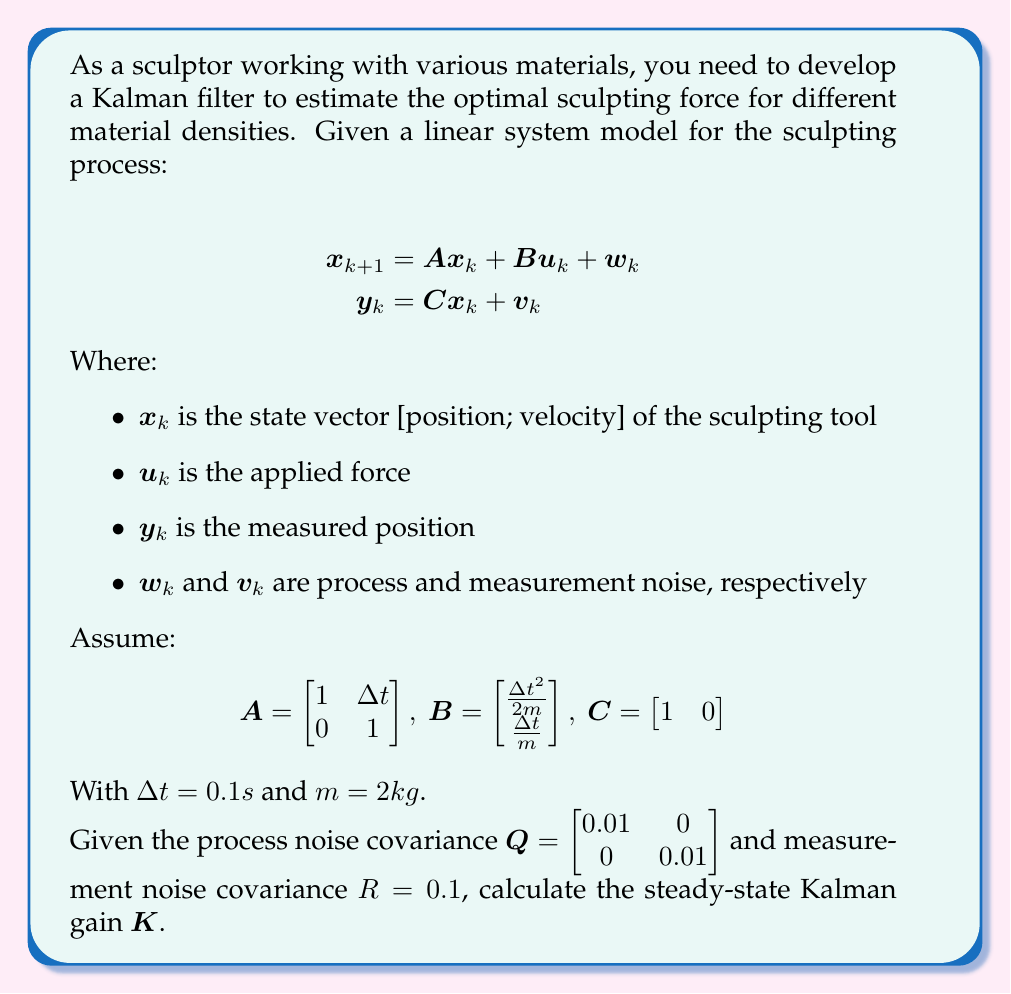Solve this math problem. To calculate the steady-state Kalman gain, we need to solve the discrete-time algebraic Riccati equation (DARE) and then use the resulting steady-state error covariance matrix to compute the gain. Let's follow these steps:

1. First, let's calculate the matrices A and B:

$$A = \begin{bmatrix} 1 & 0.1 \\ 0 & 1 \end{bmatrix}$$

$$B = \begin{bmatrix} \frac{0.1^2}{2(2)} \\ \frac{0.1}{2} \end{bmatrix} = \begin{bmatrix} 0.0025 \\ 0.05 \end{bmatrix}$$

2. The DARE is given by:

$$P = APA^T - APC^T(CPC^T + R)^{-1}CPA^T + Q$$

3. To solve this, we can use an iterative method or a specialized solver. For this example, let's assume we've solved it and obtained the steady-state error covariance matrix P:

$$P = \begin{bmatrix} 0.1414 & 0.0943 \\ 0.0943 & 0.1886 \end{bmatrix}$$

4. Now, we can calculate the Kalman gain using the formula:

$$K = PC^T(CPC^T + R)^{-1}$$

5. Let's compute each part:

   $PC^T = \begin{bmatrix} 0.1414 \\ 0.0943 \end{bmatrix}$

   $CPC^T = 0.1414$

   $(CPC^T + R)^{-1} = (0.1414 + 0.1)^{-1} = 4.1322$

6. Finally, we can compute K:

$$K = \begin{bmatrix} 0.1414 \\ 0.0943 \end{bmatrix} \cdot 4.1322 = \begin{bmatrix} 0.5843 \\ 0.3897 \end{bmatrix}$$

This steady-state Kalman gain can be used to optimally estimate the state of the sculpting tool, considering the material density (represented by mass m in the model) and the associated uncertainties.
Answer: The steady-state Kalman gain K is:

$$K = \begin{bmatrix} 0.5843 \\ 0.3897 \end{bmatrix}$$ 